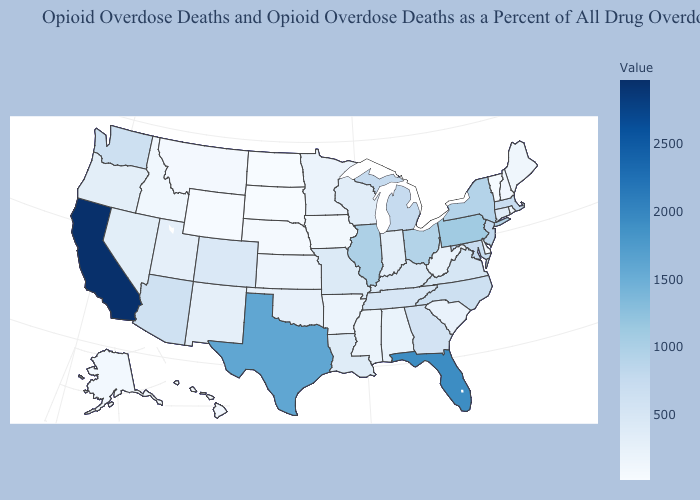Does North Dakota have the lowest value in the USA?
Give a very brief answer. Yes. Does California have the highest value in the USA?
Short answer required. Yes. Which states have the highest value in the USA?
Quick response, please. California. Among the states that border Illinois , does Indiana have the highest value?
Short answer required. No. Does California have the highest value in the USA?
Answer briefly. Yes. Does Pennsylvania have the lowest value in the Northeast?
Quick response, please. No. Which states have the lowest value in the West?
Short answer required. Wyoming. Does the map have missing data?
Quick response, please. No. 